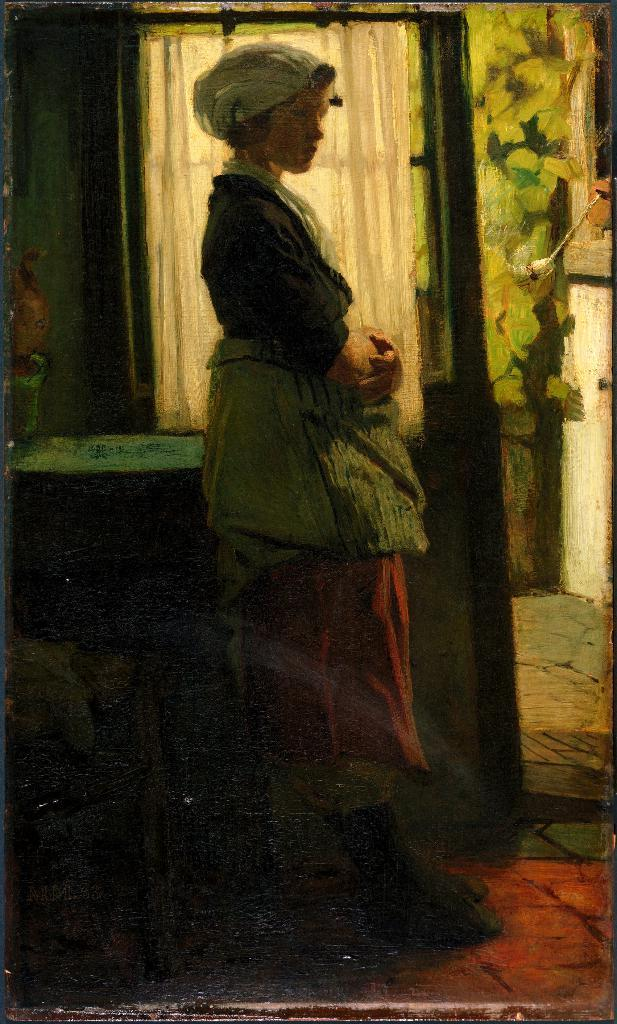What is the primary subject of the image? There is a woman standing in the image. Where is the woman positioned in relation to the floor? The woman is standing on the floor. What is located near the woman in the image? There is a table beside the woman. What is on the table in the image? There is an object on the table. What can be seen behind the woman in the image? There is a wall behind the woman. What type of religious symbol can be seen on the woman's forehead in the image? There is no religious symbol visible on the woman's forehead in the image. Can you tell me how many toads are sitting on the table in the image? There are no toads present in the image; the object on the table is not a toad. 